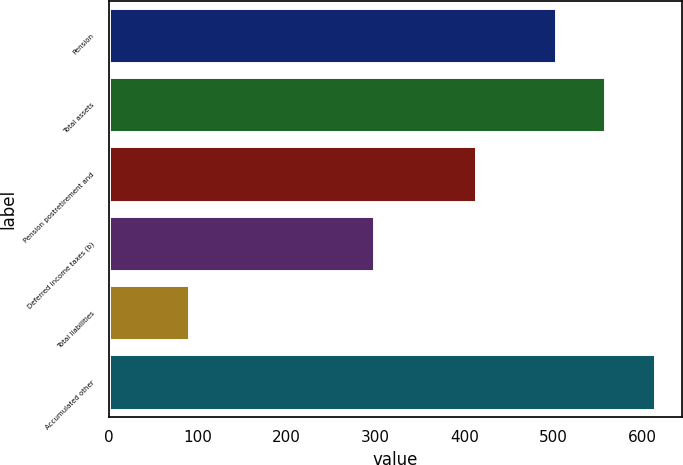<chart> <loc_0><loc_0><loc_500><loc_500><bar_chart><fcel>Pension<fcel>Total assets<fcel>Pension postretirement and<fcel>Deferred income taxes (b)<fcel>Total liabilities<fcel>Accumulated other<nl><fcel>502.9<fcel>558.67<fcel>412.6<fcel>298.9<fcel>89.97<fcel>614.44<nl></chart> 